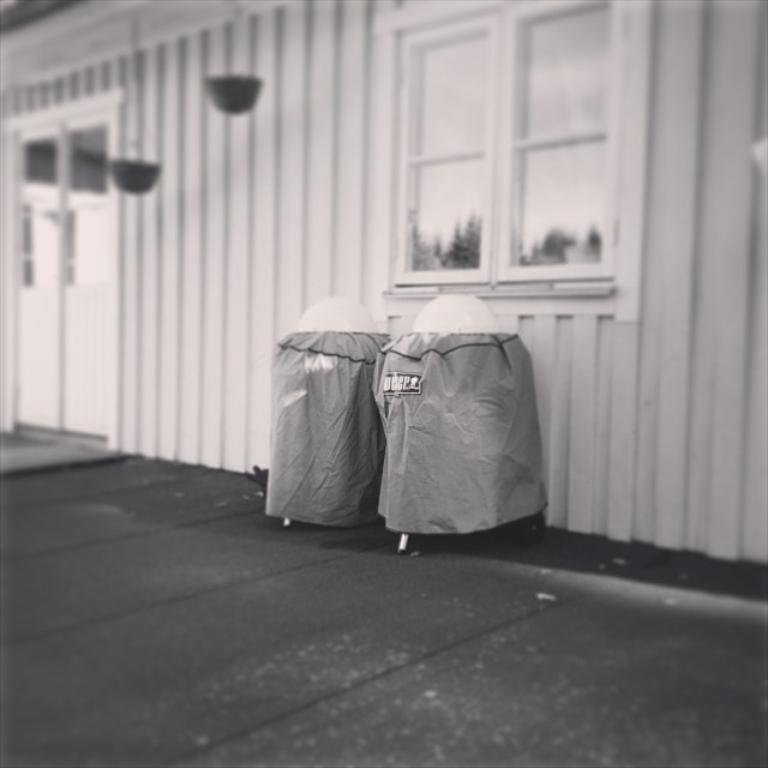In one or two sentences, can you explain what this image depicts? In this image there is a glass door. There are pots. There is a glass window through which we can see trees. There is a wall. In front of the wall there are two trash cans. At the bottom of the image there is a wooden floor. 